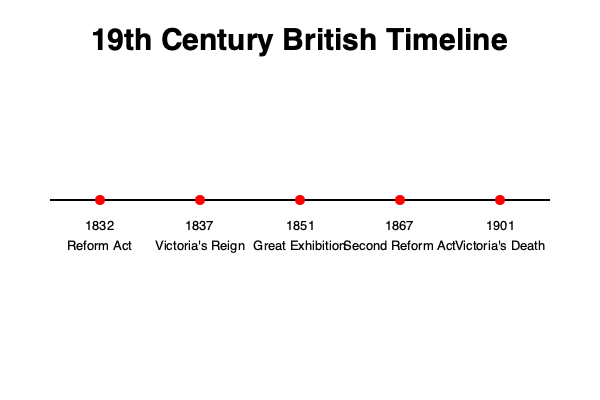Based on the timeline provided, which event marked the beginning of Queen Victoria's reign, and how many years passed between this event and the Great Exhibition? To answer this question, we need to follow these steps:

1. Identify the beginning of Queen Victoria's reign on the timeline:
   - The event "Victoria's Reign" is marked in 1837.

2. Locate the Great Exhibition on the timeline:
   - The Great Exhibition is shown to have occurred in 1851.

3. Calculate the time difference:
   - To find the number of years between these two events, we subtract the earlier year from the later year.
   - $1851 - 1837 = 14$ years

Therefore, Queen Victoria's reign began in 1837, and 14 years passed between this event and the Great Exhibition in 1851.
Answer: 1837; 14 years 